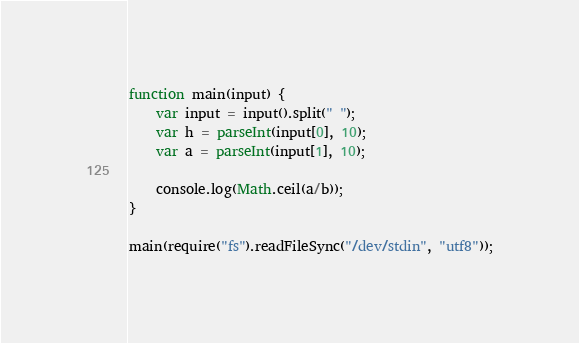<code> <loc_0><loc_0><loc_500><loc_500><_JavaScript_>function main(input) {
    var input = input().split(" ");
    var h = parseInt(input[0], 10);
    var a = parseInt(input[1], 10);

    console.log(Math.ceil(a/b));
}

main(require("fs").readFileSync("/dev/stdin", "utf8"));</code> 